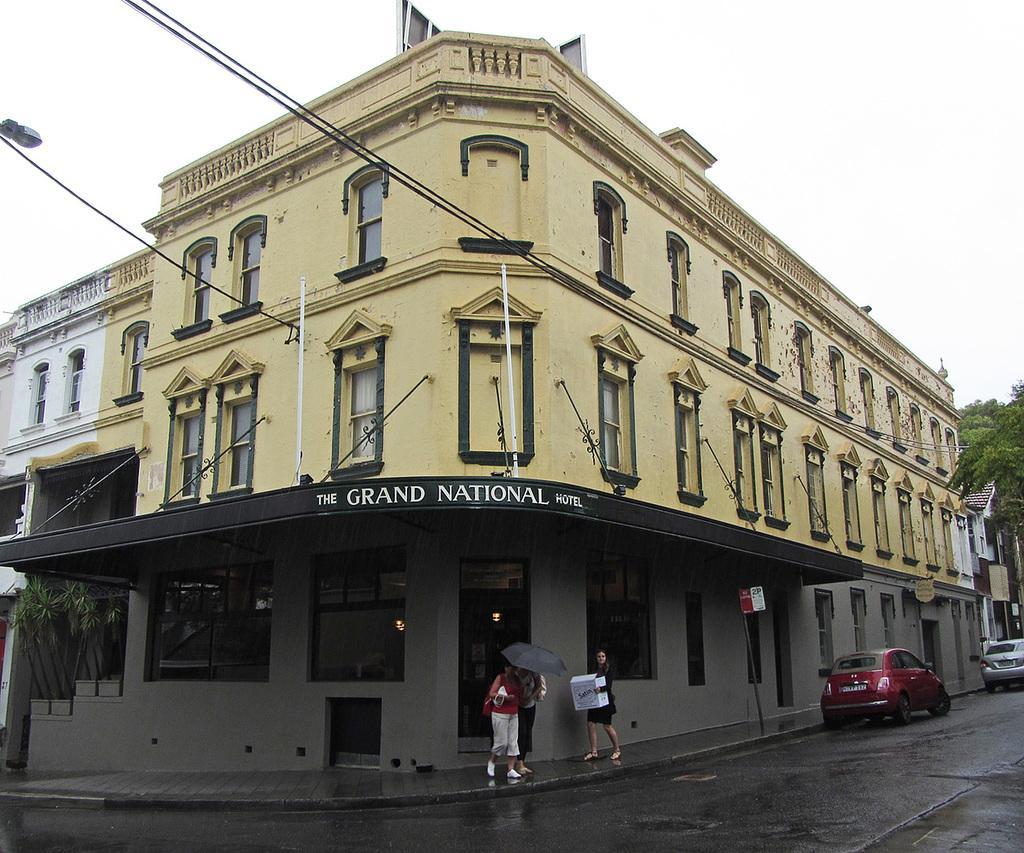Describe this image in one or two sentences. This is an outside view. Here I can see a building. On the right side there are two cars on the road and also there is a tree. Here I can see three persons are standing on the footpath. One person is carrying a bag, another person is holding an umbrella. At the top of the image I can see the sky. 